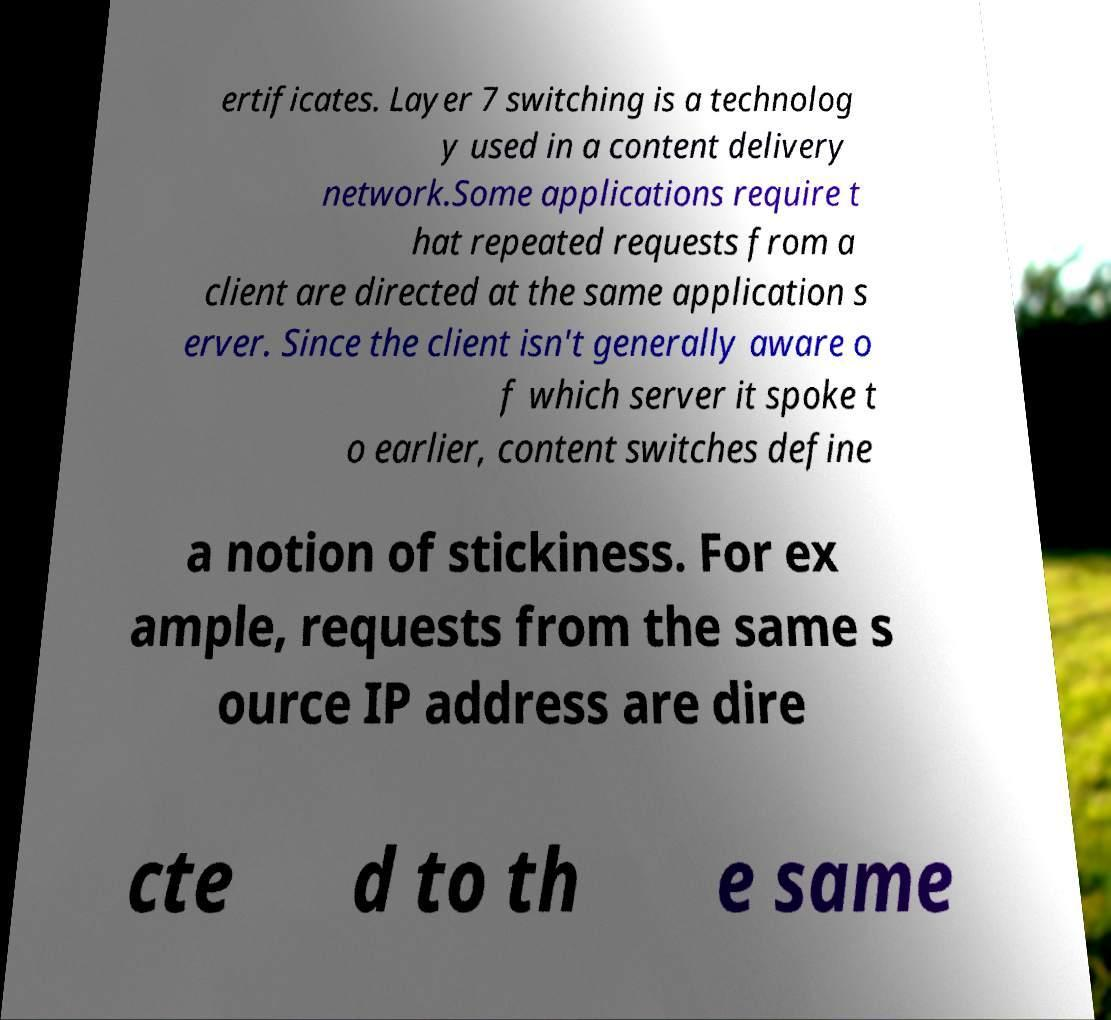There's text embedded in this image that I need extracted. Can you transcribe it verbatim? ertificates. Layer 7 switching is a technolog y used in a content delivery network.Some applications require t hat repeated requests from a client are directed at the same application s erver. Since the client isn't generally aware o f which server it spoke t o earlier, content switches define a notion of stickiness. For ex ample, requests from the same s ource IP address are dire cte d to th e same 